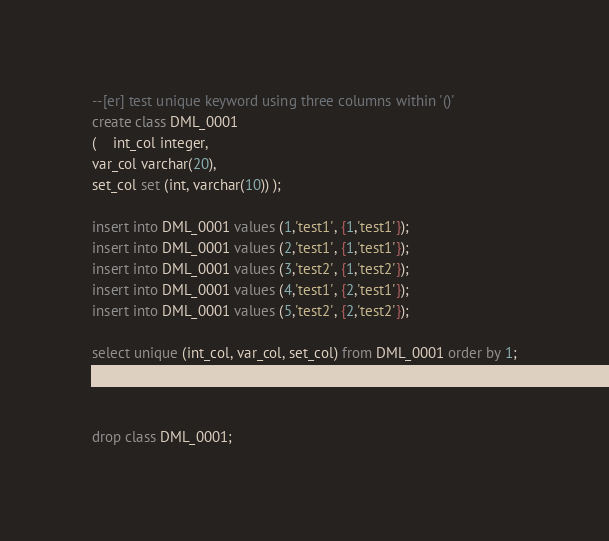<code> <loc_0><loc_0><loc_500><loc_500><_SQL_>--[er] test unique keyword using three columns within '()'
create class DML_0001 
( 	int_col integer,
var_col varchar(20),
set_col set (int, varchar(10)) );

insert into DML_0001 values (1,'test1', {1,'test1'});
insert into DML_0001 values (2,'test1', {1,'test1'});
insert into DML_0001 values (3,'test2', {1,'test2'});
insert into DML_0001 values (4,'test1', {2,'test1'});
insert into DML_0001 values (5,'test2', {2,'test2'});

select unique (int_col, var_col, set_col) from DML_0001 order by 1;



drop class DML_0001;
</code> 